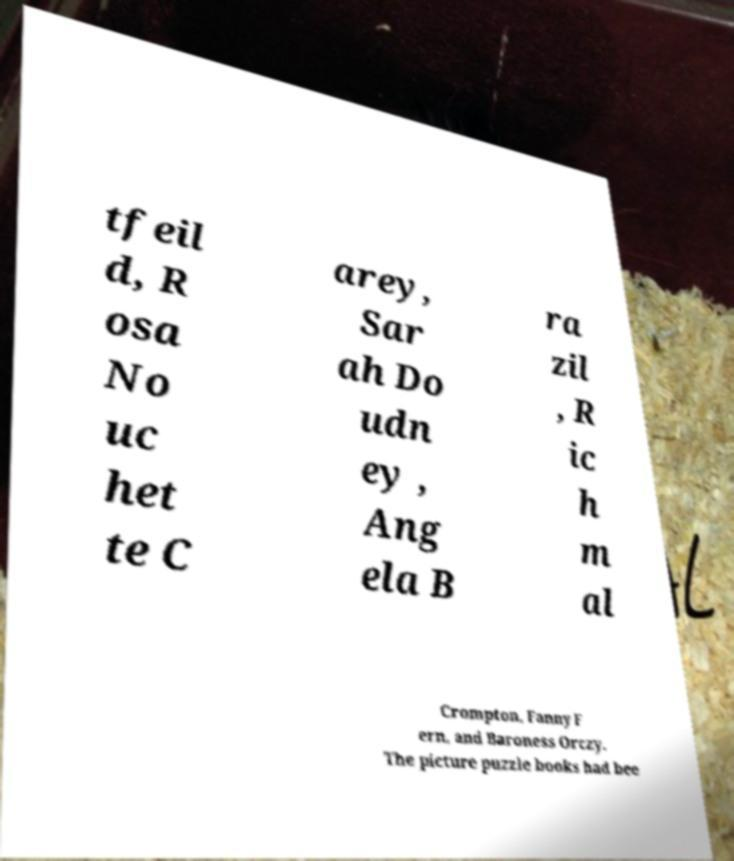Can you accurately transcribe the text from the provided image for me? tfeil d, R osa No uc het te C arey, Sar ah Do udn ey , Ang ela B ra zil , R ic h m al Crompton, Fanny F ern, and Baroness Orczy. The picture puzzle books had bee 